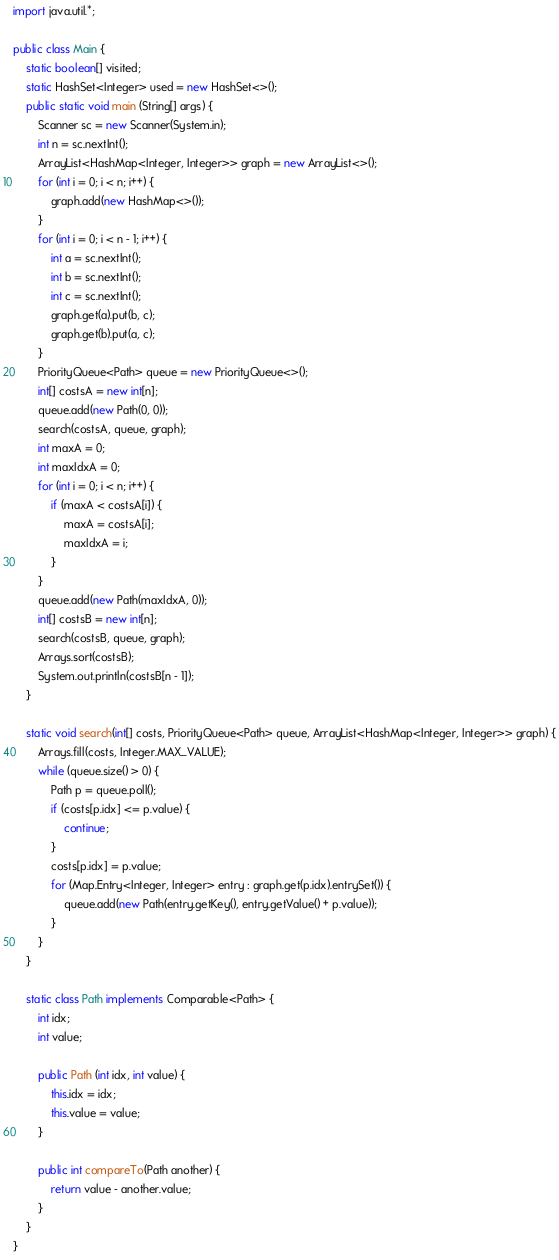<code> <loc_0><loc_0><loc_500><loc_500><_Java_>import java.util.*;

public class Main {
	static boolean[] visited;
	static HashSet<Integer> used = new HashSet<>();
	public static void main (String[] args) {
		Scanner sc = new Scanner(System.in);
		int n = sc.nextInt();
	    ArrayList<HashMap<Integer, Integer>> graph = new ArrayList<>();
		for (int i = 0; i < n; i++) {
		    graph.add(new HashMap<>());
		}
		for (int i = 0; i < n - 1; i++) {
		    int a = sc.nextInt();
		    int b = sc.nextInt();
		    int c = sc.nextInt();
		    graph.get(a).put(b, c);
		    graph.get(b).put(a, c);
		}
		PriorityQueue<Path> queue = new PriorityQueue<>();
		int[] costsA = new int[n];
		queue.add(new Path(0, 0));
		search(costsA, queue, graph);
		int maxA = 0;
		int maxIdxA = 0;
		for (int i = 0; i < n; i++) {
		    if (maxA < costsA[i]) {
		        maxA = costsA[i];
		        maxIdxA = i;
		    }
		}
		queue.add(new Path(maxIdxA, 0));
		int[] costsB = new int[n];
		search(costsB, queue, graph);
		Arrays.sort(costsB);
		System.out.println(costsB[n - 1]);
	}
	
	static void search(int[] costs, PriorityQueue<Path> queue, ArrayList<HashMap<Integer, Integer>> graph) {
	    Arrays.fill(costs, Integer.MAX_VALUE);
	    while (queue.size() > 0) {
	        Path p = queue.poll();
	        if (costs[p.idx] <= p.value) {
	            continue;
	        }
	        costs[p.idx] = p.value;
	        for (Map.Entry<Integer, Integer> entry : graph.get(p.idx).entrySet()) {
	            queue.add(new Path(entry.getKey(), entry.getValue() + p.value));
	        }
	    }
	}
	
	static class Path implements Comparable<Path> {
	    int idx;
	    int value;
	    
	    public Path (int idx, int value) {
	        this.idx = idx;
	        this.value = value;
	    }
	    
	    public int compareTo(Path another) {
	        return value - another.value;
	    }
	}
}

</code> 